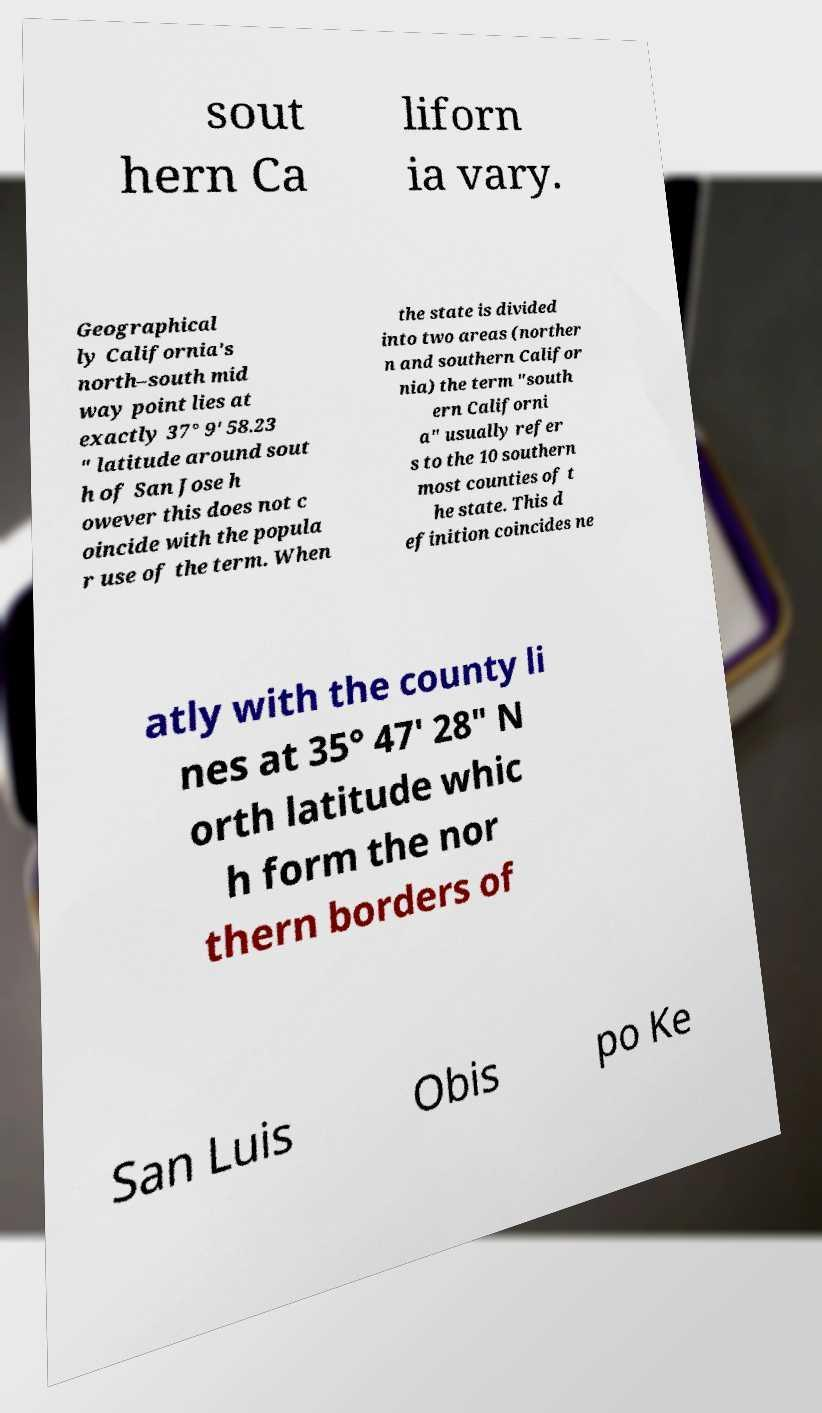I need the written content from this picture converted into text. Can you do that? sout hern Ca liforn ia vary. Geographical ly California's north–south mid way point lies at exactly 37° 9' 58.23 " latitude around sout h of San Jose h owever this does not c oincide with the popula r use of the term. When the state is divided into two areas (norther n and southern Califor nia) the term "south ern Californi a" usually refer s to the 10 southern most counties of t he state. This d efinition coincides ne atly with the county li nes at 35° 47′ 28″ N orth latitude whic h form the nor thern borders of San Luis Obis po Ke 